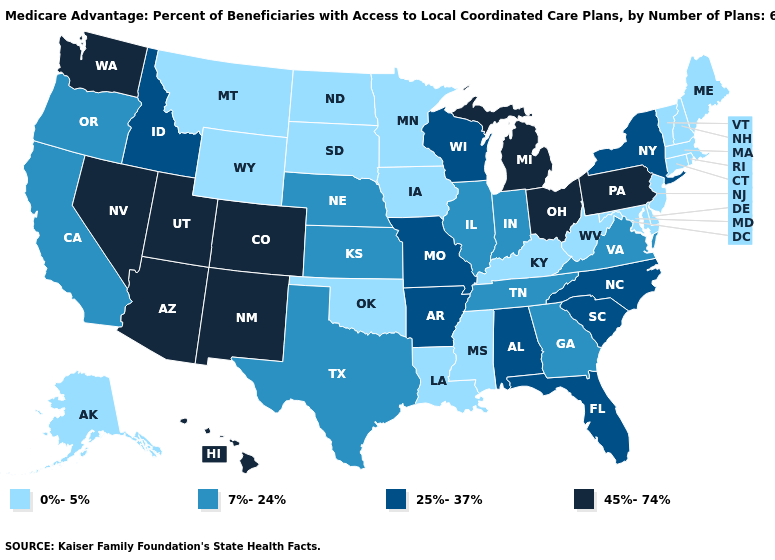Name the states that have a value in the range 25%-37%?
Quick response, please. Alabama, Arkansas, Florida, Idaho, Missouri, North Carolina, New York, South Carolina, Wisconsin. What is the highest value in the USA?
Answer briefly. 45%-74%. Does Tennessee have the highest value in the South?
Keep it brief. No. Name the states that have a value in the range 0%-5%?
Answer briefly. Alaska, Connecticut, Delaware, Iowa, Kentucky, Louisiana, Massachusetts, Maryland, Maine, Minnesota, Mississippi, Montana, North Dakota, New Hampshire, New Jersey, Oklahoma, Rhode Island, South Dakota, Vermont, West Virginia, Wyoming. Among the states that border Texas , which have the lowest value?
Keep it brief. Louisiana, Oklahoma. Which states have the highest value in the USA?
Concise answer only. Arizona, Colorado, Hawaii, Michigan, New Mexico, Nevada, Ohio, Pennsylvania, Utah, Washington. Name the states that have a value in the range 7%-24%?
Be succinct. California, Georgia, Illinois, Indiana, Kansas, Nebraska, Oregon, Tennessee, Texas, Virginia. Does Delaware have the highest value in the USA?
Short answer required. No. What is the highest value in states that border New Hampshire?
Give a very brief answer. 0%-5%. Name the states that have a value in the range 7%-24%?
Be succinct. California, Georgia, Illinois, Indiana, Kansas, Nebraska, Oregon, Tennessee, Texas, Virginia. What is the value of Mississippi?
Be succinct. 0%-5%. Does Minnesota have the lowest value in the USA?
Be succinct. Yes. Name the states that have a value in the range 0%-5%?
Write a very short answer. Alaska, Connecticut, Delaware, Iowa, Kentucky, Louisiana, Massachusetts, Maryland, Maine, Minnesota, Mississippi, Montana, North Dakota, New Hampshire, New Jersey, Oklahoma, Rhode Island, South Dakota, Vermont, West Virginia, Wyoming. What is the value of Tennessee?
Write a very short answer. 7%-24%. What is the value of Mississippi?
Give a very brief answer. 0%-5%. 